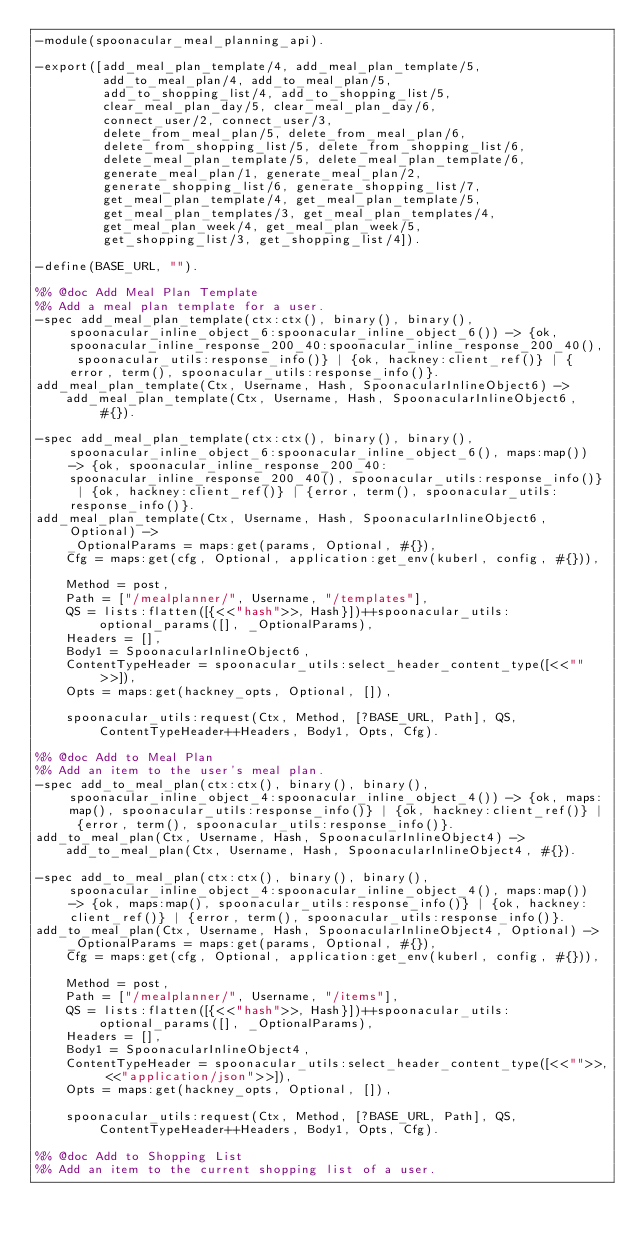<code> <loc_0><loc_0><loc_500><loc_500><_Erlang_>-module(spoonacular_meal_planning_api).

-export([add_meal_plan_template/4, add_meal_plan_template/5,
         add_to_meal_plan/4, add_to_meal_plan/5,
         add_to_shopping_list/4, add_to_shopping_list/5,
         clear_meal_plan_day/5, clear_meal_plan_day/6,
         connect_user/2, connect_user/3,
         delete_from_meal_plan/5, delete_from_meal_plan/6,
         delete_from_shopping_list/5, delete_from_shopping_list/6,
         delete_meal_plan_template/5, delete_meal_plan_template/6,
         generate_meal_plan/1, generate_meal_plan/2,
         generate_shopping_list/6, generate_shopping_list/7,
         get_meal_plan_template/4, get_meal_plan_template/5,
         get_meal_plan_templates/3, get_meal_plan_templates/4,
         get_meal_plan_week/4, get_meal_plan_week/5,
         get_shopping_list/3, get_shopping_list/4]).

-define(BASE_URL, "").

%% @doc Add Meal Plan Template
%% Add a meal plan template for a user.
-spec add_meal_plan_template(ctx:ctx(), binary(), binary(), spoonacular_inline_object_6:spoonacular_inline_object_6()) -> {ok, spoonacular_inline_response_200_40:spoonacular_inline_response_200_40(), spoonacular_utils:response_info()} | {ok, hackney:client_ref()} | {error, term(), spoonacular_utils:response_info()}.
add_meal_plan_template(Ctx, Username, Hash, SpoonacularInlineObject6) ->
    add_meal_plan_template(Ctx, Username, Hash, SpoonacularInlineObject6, #{}).

-spec add_meal_plan_template(ctx:ctx(), binary(), binary(), spoonacular_inline_object_6:spoonacular_inline_object_6(), maps:map()) -> {ok, spoonacular_inline_response_200_40:spoonacular_inline_response_200_40(), spoonacular_utils:response_info()} | {ok, hackney:client_ref()} | {error, term(), spoonacular_utils:response_info()}.
add_meal_plan_template(Ctx, Username, Hash, SpoonacularInlineObject6, Optional) ->
    _OptionalParams = maps:get(params, Optional, #{}),
    Cfg = maps:get(cfg, Optional, application:get_env(kuberl, config, #{})),

    Method = post,
    Path = ["/mealplanner/", Username, "/templates"],
    QS = lists:flatten([{<<"hash">>, Hash}])++spoonacular_utils:optional_params([], _OptionalParams),
    Headers = [],
    Body1 = SpoonacularInlineObject6,
    ContentTypeHeader = spoonacular_utils:select_header_content_type([<<"">>]),
    Opts = maps:get(hackney_opts, Optional, []),

    spoonacular_utils:request(Ctx, Method, [?BASE_URL, Path], QS, ContentTypeHeader++Headers, Body1, Opts, Cfg).

%% @doc Add to Meal Plan
%% Add an item to the user's meal plan.
-spec add_to_meal_plan(ctx:ctx(), binary(), binary(), spoonacular_inline_object_4:spoonacular_inline_object_4()) -> {ok, maps:map(), spoonacular_utils:response_info()} | {ok, hackney:client_ref()} | {error, term(), spoonacular_utils:response_info()}.
add_to_meal_plan(Ctx, Username, Hash, SpoonacularInlineObject4) ->
    add_to_meal_plan(Ctx, Username, Hash, SpoonacularInlineObject4, #{}).

-spec add_to_meal_plan(ctx:ctx(), binary(), binary(), spoonacular_inline_object_4:spoonacular_inline_object_4(), maps:map()) -> {ok, maps:map(), spoonacular_utils:response_info()} | {ok, hackney:client_ref()} | {error, term(), spoonacular_utils:response_info()}.
add_to_meal_plan(Ctx, Username, Hash, SpoonacularInlineObject4, Optional) ->
    _OptionalParams = maps:get(params, Optional, #{}),
    Cfg = maps:get(cfg, Optional, application:get_env(kuberl, config, #{})),

    Method = post,
    Path = ["/mealplanner/", Username, "/items"],
    QS = lists:flatten([{<<"hash">>, Hash}])++spoonacular_utils:optional_params([], _OptionalParams),
    Headers = [],
    Body1 = SpoonacularInlineObject4,
    ContentTypeHeader = spoonacular_utils:select_header_content_type([<<"">>, <<"application/json">>]),
    Opts = maps:get(hackney_opts, Optional, []),

    spoonacular_utils:request(Ctx, Method, [?BASE_URL, Path], QS, ContentTypeHeader++Headers, Body1, Opts, Cfg).

%% @doc Add to Shopping List
%% Add an item to the current shopping list of a user.</code> 